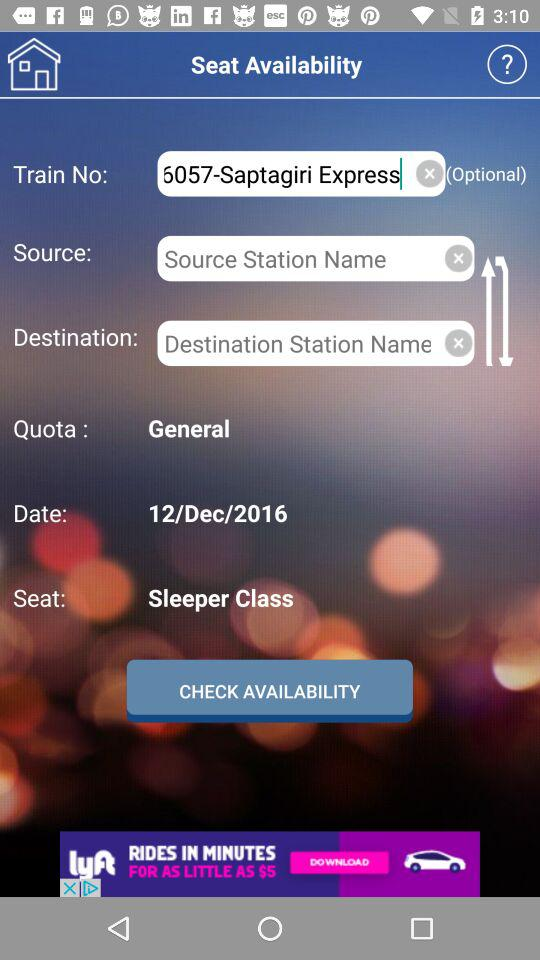What is the category of quota we opted for? You opted for the general category. 